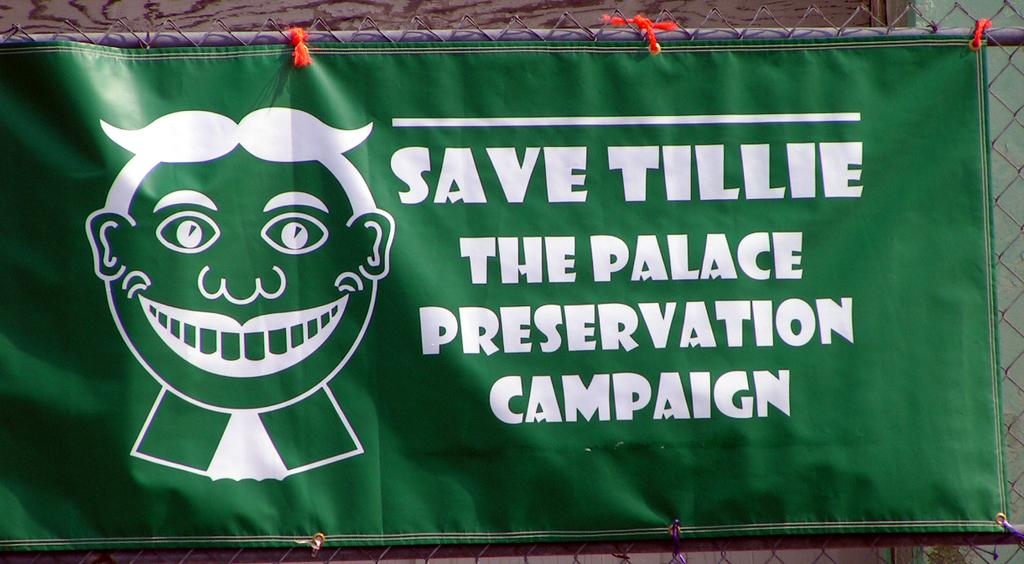<image>
Relay a brief, clear account of the picture shown. A green and white banner is hung on a fence in support of Saving Tillie. 